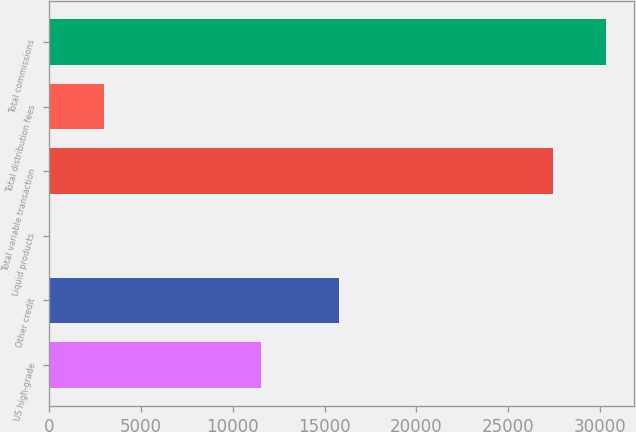Convert chart. <chart><loc_0><loc_0><loc_500><loc_500><bar_chart><fcel>US high-grade<fcel>Other credit<fcel>Liquid products<fcel>Total variable transaction<fcel>Total distribution fees<fcel>Total commissions<nl><fcel>11545<fcel>15786<fcel>81<fcel>27412<fcel>3018.2<fcel>30349.2<nl></chart> 